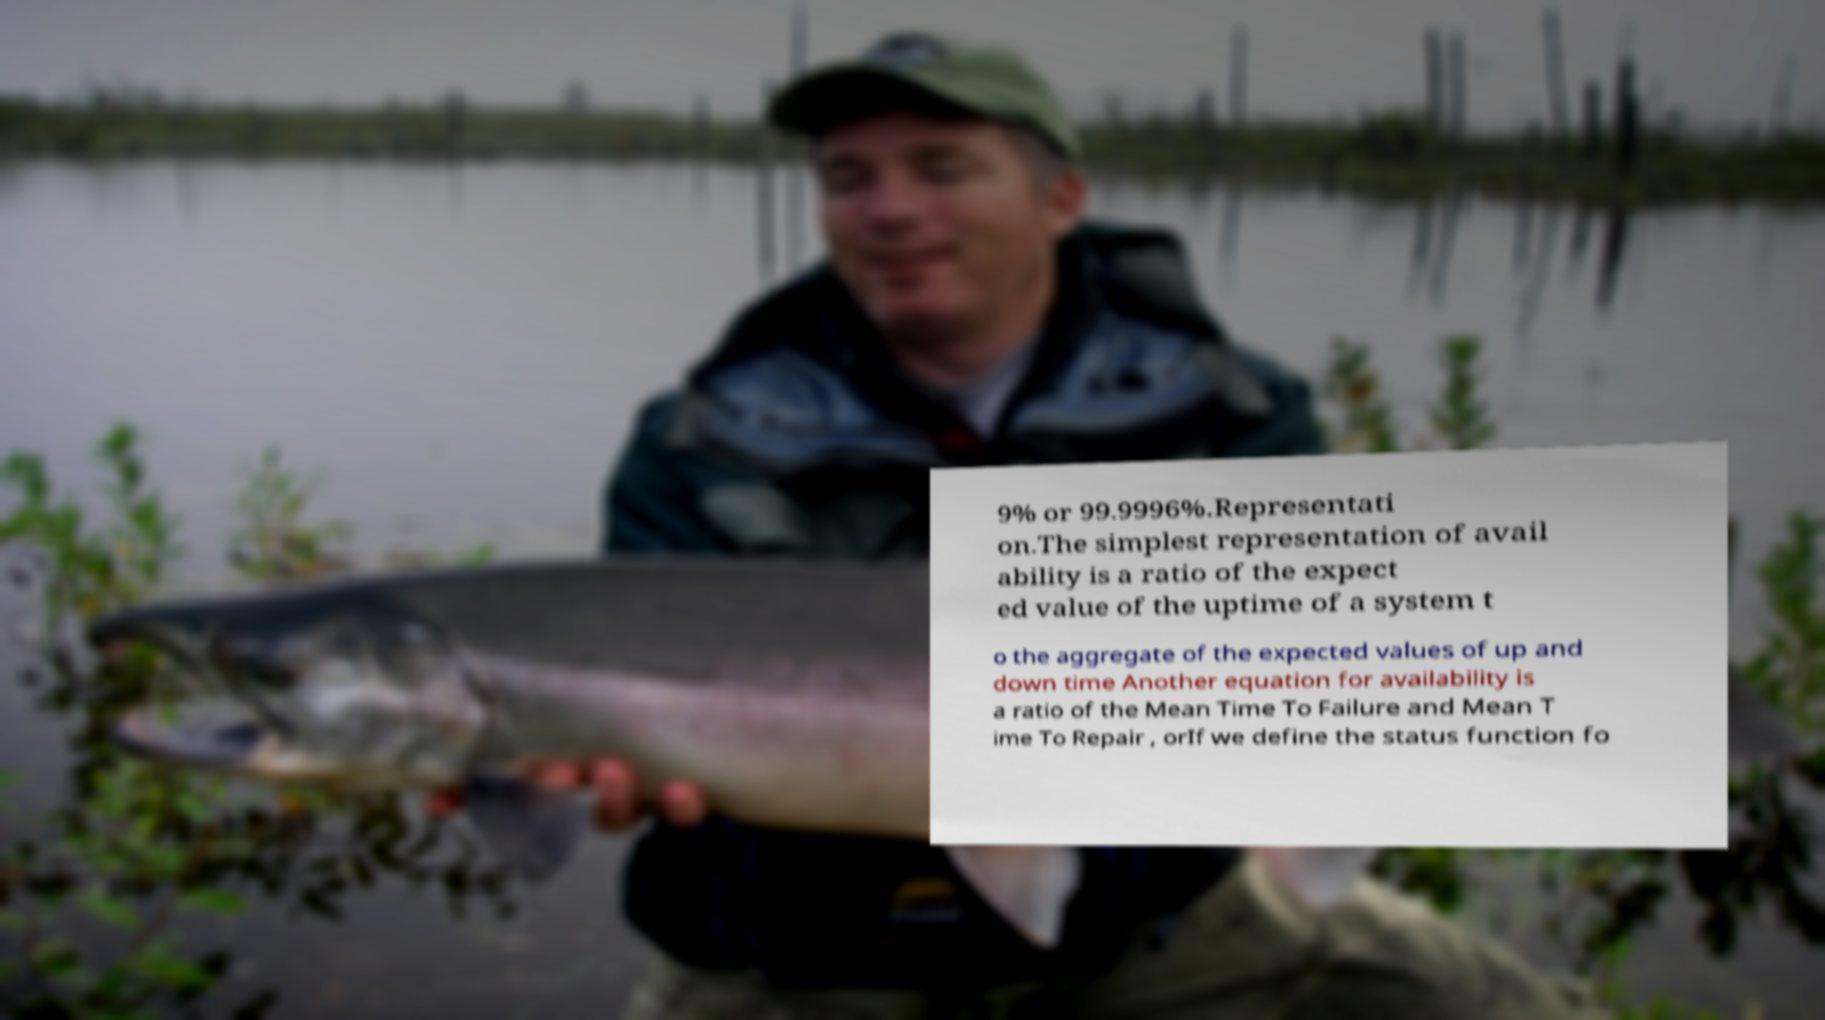For documentation purposes, I need the text within this image transcribed. Could you provide that? 9% or 99.9996%.Representati on.The simplest representation of avail ability is a ratio of the expect ed value of the uptime of a system t o the aggregate of the expected values of up and down time Another equation for availability is a ratio of the Mean Time To Failure and Mean T ime To Repair , orIf we define the status function fo 